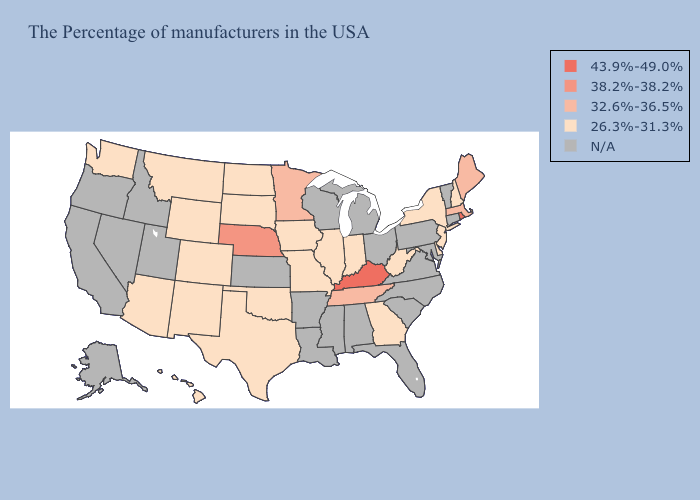Name the states that have a value in the range 32.6%-36.5%?
Answer briefly. Maine, Massachusetts, Tennessee, Minnesota. Name the states that have a value in the range 38.2%-38.2%?
Concise answer only. Nebraska. Name the states that have a value in the range 43.9%-49.0%?
Keep it brief. Rhode Island, Kentucky. Name the states that have a value in the range 43.9%-49.0%?
Quick response, please. Rhode Island, Kentucky. Does West Virginia have the highest value in the South?
Write a very short answer. No. Does the map have missing data?
Keep it brief. Yes. Name the states that have a value in the range N/A?
Write a very short answer. Vermont, Connecticut, Maryland, Pennsylvania, Virginia, North Carolina, South Carolina, Ohio, Florida, Michigan, Alabama, Wisconsin, Mississippi, Louisiana, Arkansas, Kansas, Utah, Idaho, Nevada, California, Oregon, Alaska. Name the states that have a value in the range 26.3%-31.3%?
Short answer required. New Hampshire, New York, New Jersey, Delaware, West Virginia, Georgia, Indiana, Illinois, Missouri, Iowa, Oklahoma, Texas, South Dakota, North Dakota, Wyoming, Colorado, New Mexico, Montana, Arizona, Washington, Hawaii. Name the states that have a value in the range 38.2%-38.2%?
Concise answer only. Nebraska. Among the states that border Georgia , which have the lowest value?
Quick response, please. Tennessee. Name the states that have a value in the range 43.9%-49.0%?
Concise answer only. Rhode Island, Kentucky. Which states hav the highest value in the South?
Keep it brief. Kentucky. What is the value of Louisiana?
Short answer required. N/A. 